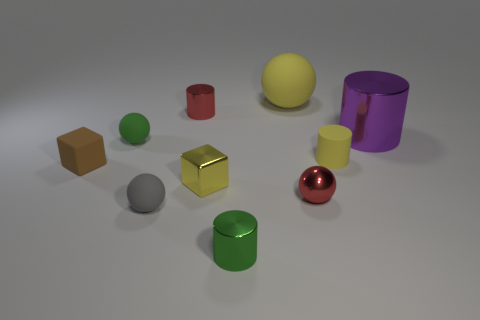Subtract all cylinders. How many objects are left? 6 Subtract 0 green blocks. How many objects are left? 10 Subtract all green spheres. Subtract all small gray rubber spheres. How many objects are left? 8 Add 6 tiny red shiny objects. How many tiny red shiny objects are left? 8 Add 6 small blue cylinders. How many small blue cylinders exist? 6 